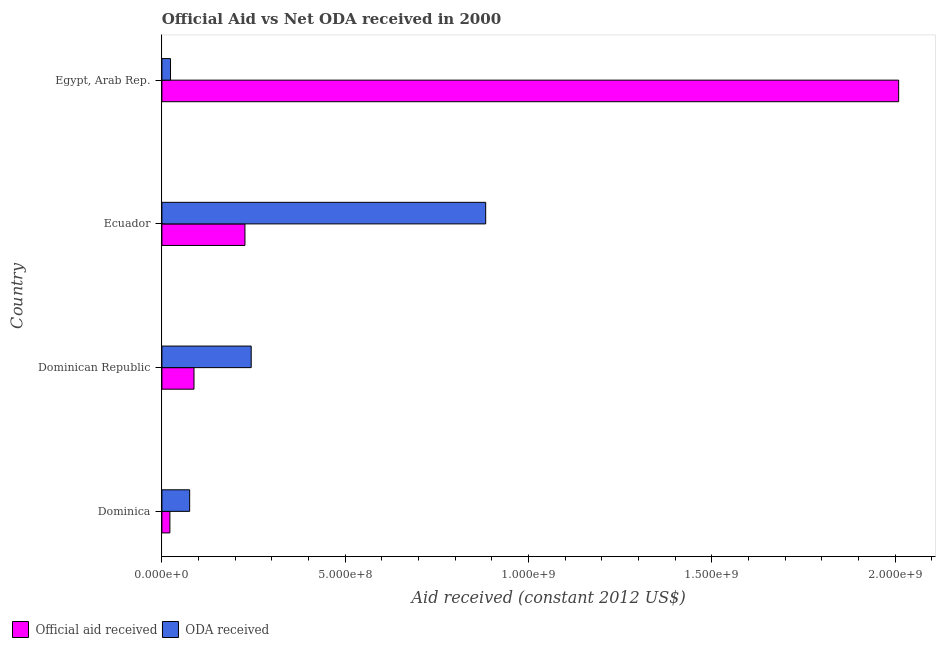How many different coloured bars are there?
Offer a terse response. 2. How many bars are there on the 1st tick from the top?
Keep it short and to the point. 2. How many bars are there on the 3rd tick from the bottom?
Give a very brief answer. 2. What is the label of the 3rd group of bars from the top?
Give a very brief answer. Dominican Republic. What is the official aid received in Dominica?
Give a very brief answer. 2.18e+07. Across all countries, what is the maximum official aid received?
Keep it short and to the point. 2.01e+09. Across all countries, what is the minimum official aid received?
Your answer should be very brief. 2.18e+07. In which country was the official aid received maximum?
Make the answer very short. Egypt, Arab Rep. In which country was the official aid received minimum?
Give a very brief answer. Dominica. What is the total official aid received in the graph?
Your answer should be compact. 2.34e+09. What is the difference between the oda received in Dominican Republic and that in Ecuador?
Your answer should be compact. -6.39e+08. What is the difference between the official aid received in Egypt, Arab Rep. and the oda received in Dominica?
Give a very brief answer. 1.93e+09. What is the average official aid received per country?
Give a very brief answer. 5.86e+08. What is the difference between the oda received and official aid received in Dominican Republic?
Make the answer very short. 1.56e+08. What is the ratio of the official aid received in Ecuador to that in Egypt, Arab Rep.?
Ensure brevity in your answer.  0.11. What is the difference between the highest and the second highest official aid received?
Ensure brevity in your answer.  1.78e+09. What is the difference between the highest and the lowest oda received?
Make the answer very short. 8.60e+08. Is the sum of the oda received in Dominican Republic and Ecuador greater than the maximum official aid received across all countries?
Offer a terse response. No. What does the 2nd bar from the top in Ecuador represents?
Your response must be concise. Official aid received. What does the 1st bar from the bottom in Egypt, Arab Rep. represents?
Provide a short and direct response. Official aid received. How many bars are there?
Your response must be concise. 8. How many countries are there in the graph?
Your response must be concise. 4. Are the values on the major ticks of X-axis written in scientific E-notation?
Keep it short and to the point. Yes. Does the graph contain grids?
Your response must be concise. No. How many legend labels are there?
Keep it short and to the point. 2. What is the title of the graph?
Give a very brief answer. Official Aid vs Net ODA received in 2000 . Does "Register a business" appear as one of the legend labels in the graph?
Your answer should be compact. No. What is the label or title of the X-axis?
Keep it short and to the point. Aid received (constant 2012 US$). What is the label or title of the Y-axis?
Your response must be concise. Country. What is the Aid received (constant 2012 US$) in Official aid received in Dominica?
Your answer should be compact. 2.18e+07. What is the Aid received (constant 2012 US$) of ODA received in Dominica?
Offer a very short reply. 7.57e+07. What is the Aid received (constant 2012 US$) of Official aid received in Dominican Republic?
Give a very brief answer. 8.75e+07. What is the Aid received (constant 2012 US$) of ODA received in Dominican Republic?
Offer a very short reply. 2.44e+08. What is the Aid received (constant 2012 US$) in Official aid received in Ecuador?
Keep it short and to the point. 2.26e+08. What is the Aid received (constant 2012 US$) in ODA received in Ecuador?
Keep it short and to the point. 8.83e+08. What is the Aid received (constant 2012 US$) of Official aid received in Egypt, Arab Rep.?
Provide a short and direct response. 2.01e+09. What is the Aid received (constant 2012 US$) in ODA received in Egypt, Arab Rep.?
Give a very brief answer. 2.35e+07. Across all countries, what is the maximum Aid received (constant 2012 US$) of Official aid received?
Keep it short and to the point. 2.01e+09. Across all countries, what is the maximum Aid received (constant 2012 US$) of ODA received?
Provide a short and direct response. 8.83e+08. Across all countries, what is the minimum Aid received (constant 2012 US$) of Official aid received?
Your answer should be very brief. 2.18e+07. Across all countries, what is the minimum Aid received (constant 2012 US$) in ODA received?
Your response must be concise. 2.35e+07. What is the total Aid received (constant 2012 US$) of Official aid received in the graph?
Your answer should be very brief. 2.34e+09. What is the total Aid received (constant 2012 US$) in ODA received in the graph?
Provide a succinct answer. 1.23e+09. What is the difference between the Aid received (constant 2012 US$) in Official aid received in Dominica and that in Dominican Republic?
Keep it short and to the point. -6.57e+07. What is the difference between the Aid received (constant 2012 US$) of ODA received in Dominica and that in Dominican Republic?
Your answer should be very brief. -1.68e+08. What is the difference between the Aid received (constant 2012 US$) of Official aid received in Dominica and that in Ecuador?
Provide a short and direct response. -2.05e+08. What is the difference between the Aid received (constant 2012 US$) in ODA received in Dominica and that in Ecuador?
Give a very brief answer. -8.07e+08. What is the difference between the Aid received (constant 2012 US$) of Official aid received in Dominica and that in Egypt, Arab Rep.?
Your answer should be compact. -1.99e+09. What is the difference between the Aid received (constant 2012 US$) in ODA received in Dominica and that in Egypt, Arab Rep.?
Make the answer very short. 5.22e+07. What is the difference between the Aid received (constant 2012 US$) in Official aid received in Dominican Republic and that in Ecuador?
Offer a terse response. -1.39e+08. What is the difference between the Aid received (constant 2012 US$) in ODA received in Dominican Republic and that in Ecuador?
Provide a succinct answer. -6.39e+08. What is the difference between the Aid received (constant 2012 US$) of Official aid received in Dominican Republic and that in Egypt, Arab Rep.?
Ensure brevity in your answer.  -1.92e+09. What is the difference between the Aid received (constant 2012 US$) of ODA received in Dominican Republic and that in Egypt, Arab Rep.?
Keep it short and to the point. 2.20e+08. What is the difference between the Aid received (constant 2012 US$) in Official aid received in Ecuador and that in Egypt, Arab Rep.?
Your answer should be very brief. -1.78e+09. What is the difference between the Aid received (constant 2012 US$) in ODA received in Ecuador and that in Egypt, Arab Rep.?
Ensure brevity in your answer.  8.60e+08. What is the difference between the Aid received (constant 2012 US$) in Official aid received in Dominica and the Aid received (constant 2012 US$) in ODA received in Dominican Republic?
Offer a very short reply. -2.22e+08. What is the difference between the Aid received (constant 2012 US$) in Official aid received in Dominica and the Aid received (constant 2012 US$) in ODA received in Ecuador?
Provide a short and direct response. -8.61e+08. What is the difference between the Aid received (constant 2012 US$) of Official aid received in Dominica and the Aid received (constant 2012 US$) of ODA received in Egypt, Arab Rep.?
Offer a very short reply. -1.69e+06. What is the difference between the Aid received (constant 2012 US$) in Official aid received in Dominican Republic and the Aid received (constant 2012 US$) in ODA received in Ecuador?
Provide a succinct answer. -7.95e+08. What is the difference between the Aid received (constant 2012 US$) of Official aid received in Dominican Republic and the Aid received (constant 2012 US$) of ODA received in Egypt, Arab Rep.?
Make the answer very short. 6.40e+07. What is the difference between the Aid received (constant 2012 US$) in Official aid received in Ecuador and the Aid received (constant 2012 US$) in ODA received in Egypt, Arab Rep.?
Provide a succinct answer. 2.03e+08. What is the average Aid received (constant 2012 US$) in Official aid received per country?
Keep it short and to the point. 5.86e+08. What is the average Aid received (constant 2012 US$) of ODA received per country?
Offer a very short reply. 3.06e+08. What is the difference between the Aid received (constant 2012 US$) of Official aid received and Aid received (constant 2012 US$) of ODA received in Dominica?
Ensure brevity in your answer.  -5.39e+07. What is the difference between the Aid received (constant 2012 US$) of Official aid received and Aid received (constant 2012 US$) of ODA received in Dominican Republic?
Give a very brief answer. -1.56e+08. What is the difference between the Aid received (constant 2012 US$) in Official aid received and Aid received (constant 2012 US$) in ODA received in Ecuador?
Provide a short and direct response. -6.57e+08. What is the difference between the Aid received (constant 2012 US$) in Official aid received and Aid received (constant 2012 US$) in ODA received in Egypt, Arab Rep.?
Ensure brevity in your answer.  1.99e+09. What is the ratio of the Aid received (constant 2012 US$) of Official aid received in Dominica to that in Dominican Republic?
Give a very brief answer. 0.25. What is the ratio of the Aid received (constant 2012 US$) in ODA received in Dominica to that in Dominican Republic?
Ensure brevity in your answer.  0.31. What is the ratio of the Aid received (constant 2012 US$) in Official aid received in Dominica to that in Ecuador?
Provide a succinct answer. 0.1. What is the ratio of the Aid received (constant 2012 US$) in ODA received in Dominica to that in Ecuador?
Your answer should be compact. 0.09. What is the ratio of the Aid received (constant 2012 US$) of Official aid received in Dominica to that in Egypt, Arab Rep.?
Your answer should be very brief. 0.01. What is the ratio of the Aid received (constant 2012 US$) of ODA received in Dominica to that in Egypt, Arab Rep.?
Your response must be concise. 3.22. What is the ratio of the Aid received (constant 2012 US$) in Official aid received in Dominican Republic to that in Ecuador?
Provide a short and direct response. 0.39. What is the ratio of the Aid received (constant 2012 US$) in ODA received in Dominican Republic to that in Ecuador?
Keep it short and to the point. 0.28. What is the ratio of the Aid received (constant 2012 US$) in Official aid received in Dominican Republic to that in Egypt, Arab Rep.?
Give a very brief answer. 0.04. What is the ratio of the Aid received (constant 2012 US$) of ODA received in Dominican Republic to that in Egypt, Arab Rep.?
Provide a short and direct response. 10.37. What is the ratio of the Aid received (constant 2012 US$) of Official aid received in Ecuador to that in Egypt, Arab Rep.?
Make the answer very short. 0.11. What is the ratio of the Aid received (constant 2012 US$) of ODA received in Ecuador to that in Egypt, Arab Rep.?
Your response must be concise. 37.61. What is the difference between the highest and the second highest Aid received (constant 2012 US$) of Official aid received?
Your answer should be compact. 1.78e+09. What is the difference between the highest and the second highest Aid received (constant 2012 US$) in ODA received?
Your answer should be very brief. 6.39e+08. What is the difference between the highest and the lowest Aid received (constant 2012 US$) in Official aid received?
Offer a very short reply. 1.99e+09. What is the difference between the highest and the lowest Aid received (constant 2012 US$) in ODA received?
Make the answer very short. 8.60e+08. 